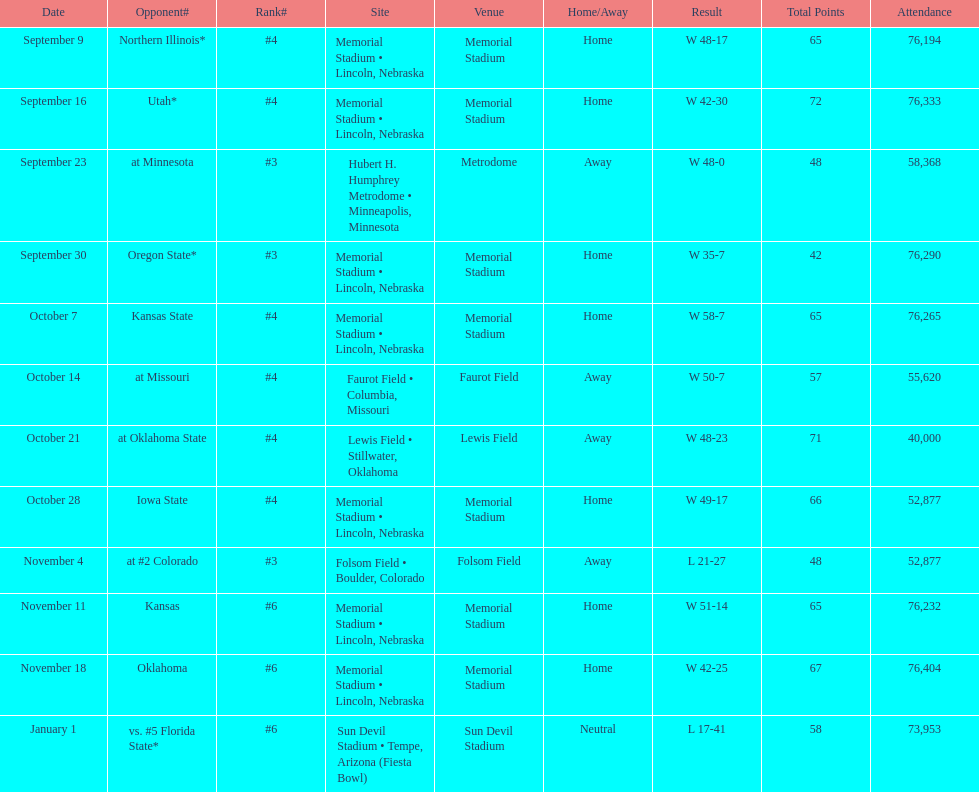When can we expect the first game to occur? September 9. Could you parse the entire table? {'header': ['Date', 'Opponent#', 'Rank#', 'Site', 'Venue', 'Home/Away', 'Result', 'Total Points', 'Attendance'], 'rows': [['September 9', 'Northern Illinois*', '#4', 'Memorial Stadium • Lincoln, Nebraska', 'Memorial Stadium', 'Home', 'W\xa048-17', '65', '76,194'], ['September 16', 'Utah*', '#4', 'Memorial Stadium • Lincoln, Nebraska', 'Memorial Stadium', 'Home', 'W\xa042-30', '72', '76,333'], ['September 23', 'at\xa0Minnesota', '#3', 'Hubert H. Humphrey Metrodome • Minneapolis, Minnesota', 'Metrodome', 'Away', 'W\xa048-0', '48', '58,368'], ['September 30', 'Oregon State*', '#3', 'Memorial Stadium • Lincoln, Nebraska', 'Memorial Stadium', 'Home', 'W\xa035-7', '42', '76,290'], ['October 7', 'Kansas State', '#4', 'Memorial Stadium • Lincoln, Nebraska', 'Memorial Stadium', 'Home', 'W\xa058-7', '65', '76,265'], ['October 14', 'at\xa0Missouri', '#4', 'Faurot Field • Columbia, Missouri', 'Faurot Field', 'Away', 'W\xa050-7', '57', '55,620'], ['October 21', 'at\xa0Oklahoma State', '#4', 'Lewis Field • Stillwater, Oklahoma', 'Lewis Field', 'Away', 'W\xa048-23', '71', '40,000'], ['October 28', 'Iowa State', '#4', 'Memorial Stadium • Lincoln, Nebraska', 'Memorial Stadium', 'Home', 'W\xa049-17', '66', '52,877'], ['November 4', 'at\xa0#2\xa0Colorado', '#3', 'Folsom Field • Boulder, Colorado', 'Folsom Field', 'Away', 'L\xa021-27', '48', '52,877'], ['November 11', 'Kansas', '#6', 'Memorial Stadium • Lincoln, Nebraska', 'Memorial Stadium', 'Home', 'W\xa051-14', '65', '76,232'], ['November 18', 'Oklahoma', '#6', 'Memorial Stadium • Lincoln, Nebraska', 'Memorial Stadium', 'Home', 'W\xa042-25', '67', '76,404'], ['January 1', 'vs.\xa0#5\xa0Florida State*', '#6', 'Sun Devil Stadium • Tempe, Arizona (Fiesta Bowl)', 'Sun Devil Stadium', 'Neutral', 'L\xa017-41', '58', '73,953']]} 